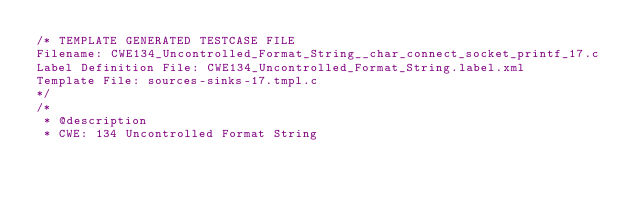Convert code to text. <code><loc_0><loc_0><loc_500><loc_500><_C_>/* TEMPLATE GENERATED TESTCASE FILE
Filename: CWE134_Uncontrolled_Format_String__char_connect_socket_printf_17.c
Label Definition File: CWE134_Uncontrolled_Format_String.label.xml
Template File: sources-sinks-17.tmpl.c
*/
/*
 * @description
 * CWE: 134 Uncontrolled Format String</code> 